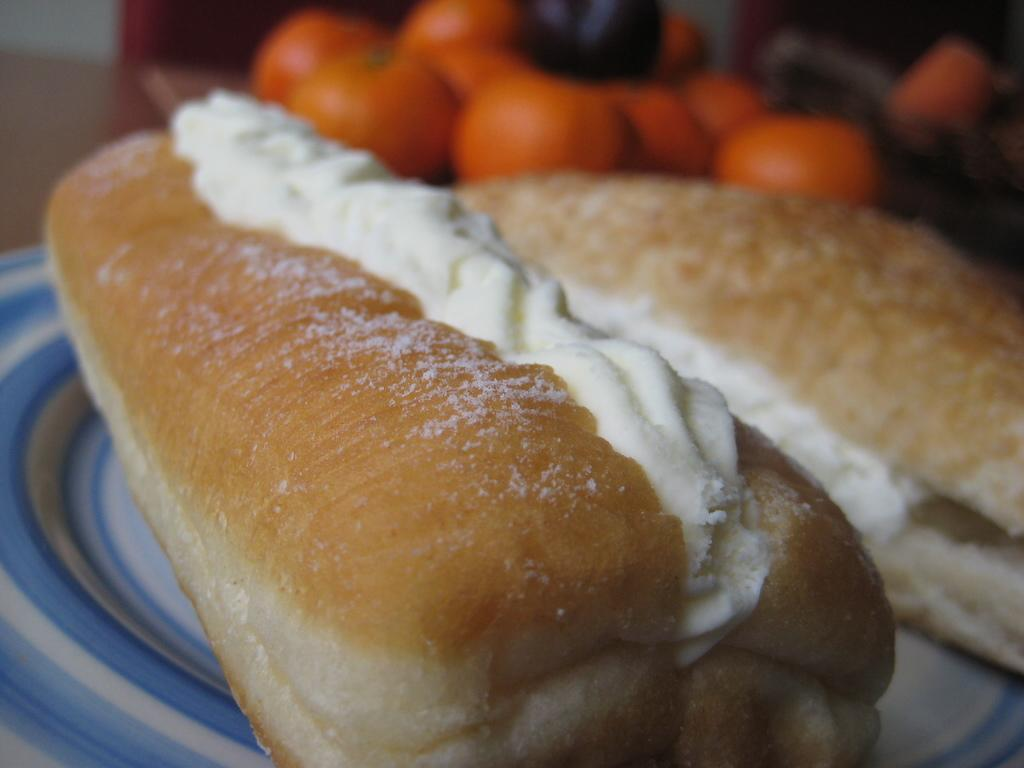What type of food is on the plate in the image? There are two hot dog buns on a plate in the image. What is on top of the hot dog buns? The hot dog buns have cream on them. What color items can be seen in the background of the image? There are orange color items in the background. What type of plants can be seen growing on the bridge in the image? There is no bridge or plants present in the image. How many feet are visible in the image? There are no feet visible in the image. 